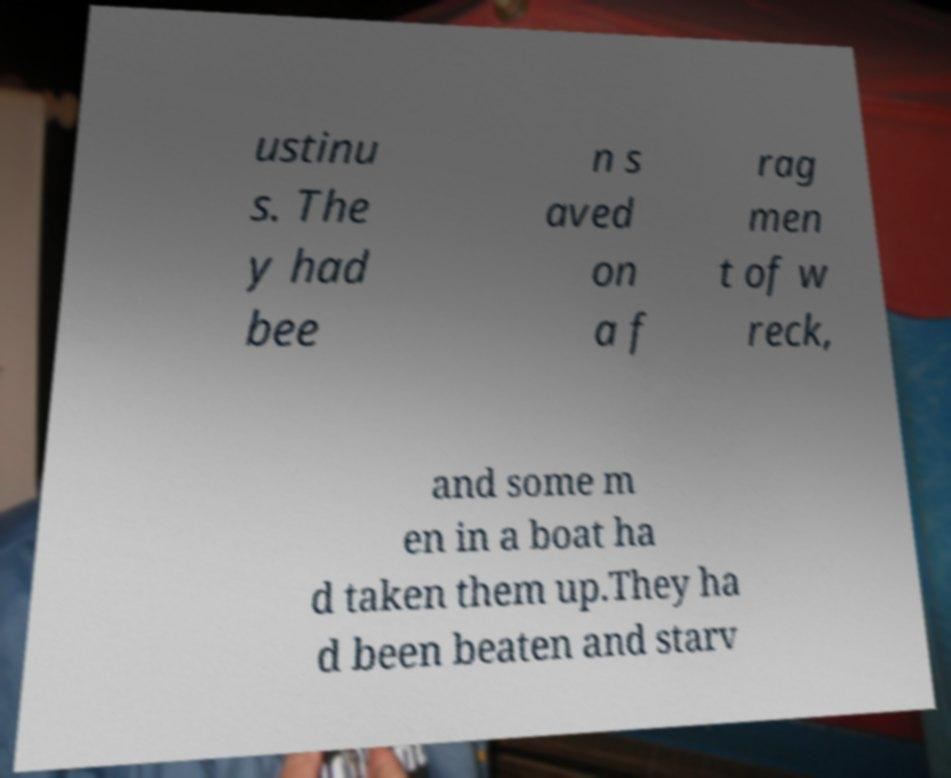There's text embedded in this image that I need extracted. Can you transcribe it verbatim? ustinu s. The y had bee n s aved on a f rag men t of w reck, and some m en in a boat ha d taken them up.They ha d been beaten and starv 